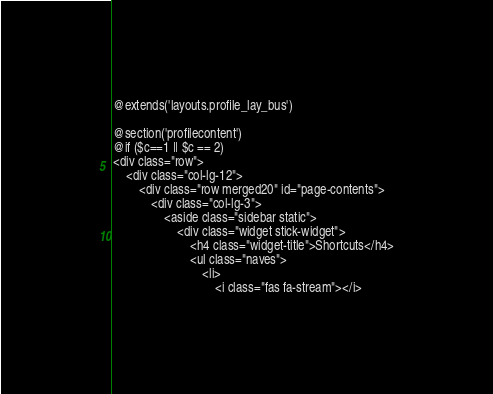<code> <loc_0><loc_0><loc_500><loc_500><_PHP_>@extends('layouts.profile_lay_bus')

@section('profilecontent')
@if ($c==1 || $c == 2)
<div class="row">
    <div class="col-lg-12">
        <div class="row merged20" id="page-contents">
            <div class="col-lg-3">
                <aside class="sidebar static">
                    <div class="widget stick-widget">
                        <h4 class="widget-title">Shortcuts</h4>
                        <ul class="naves">
                            <li>
                                <i class="fas fa-stream"></i></code> 